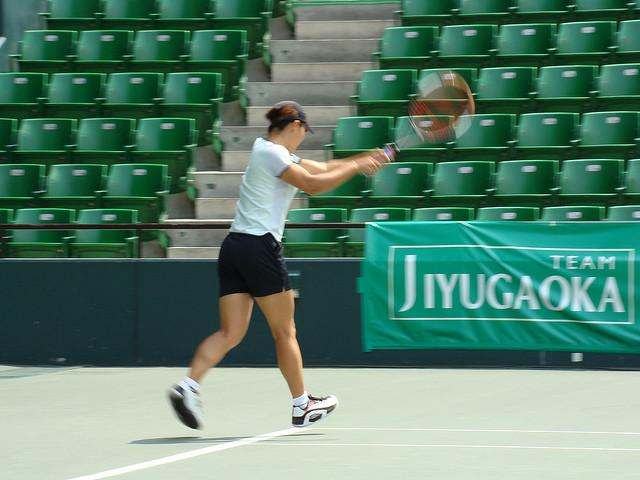What person played a similar sport to this person? serena williams 